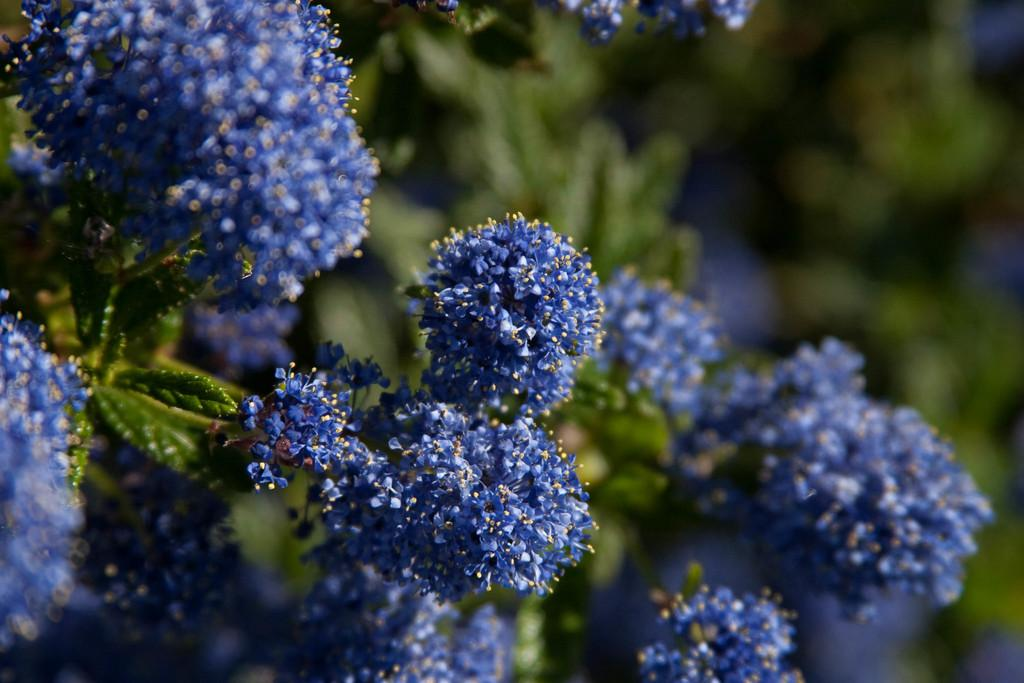What type of living organisms can be seen in the image? Plants can be seen in the image. What specific feature of the plants is visible? The plants have flowers. What color are the flowers? The flowers are blue in color. What can be observed about the background of the image? The background of the image is green, and it is blurred. How many sisters are sitting on the floor in the image? There are no sisters or floor present in the image; it features plants with blue flowers and a green, blurred background. 